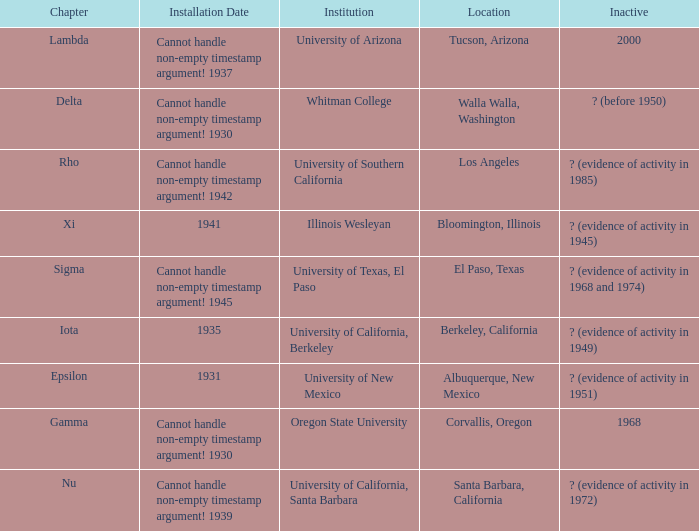What is the significance of the inactive state for the university of texas, el paso? ? (evidence of activity in 1968 and 1974). 